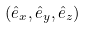Convert formula to latex. <formula><loc_0><loc_0><loc_500><loc_500>( \hat { e } _ { x } , \hat { e } _ { y } , \hat { e } _ { z } )</formula> 